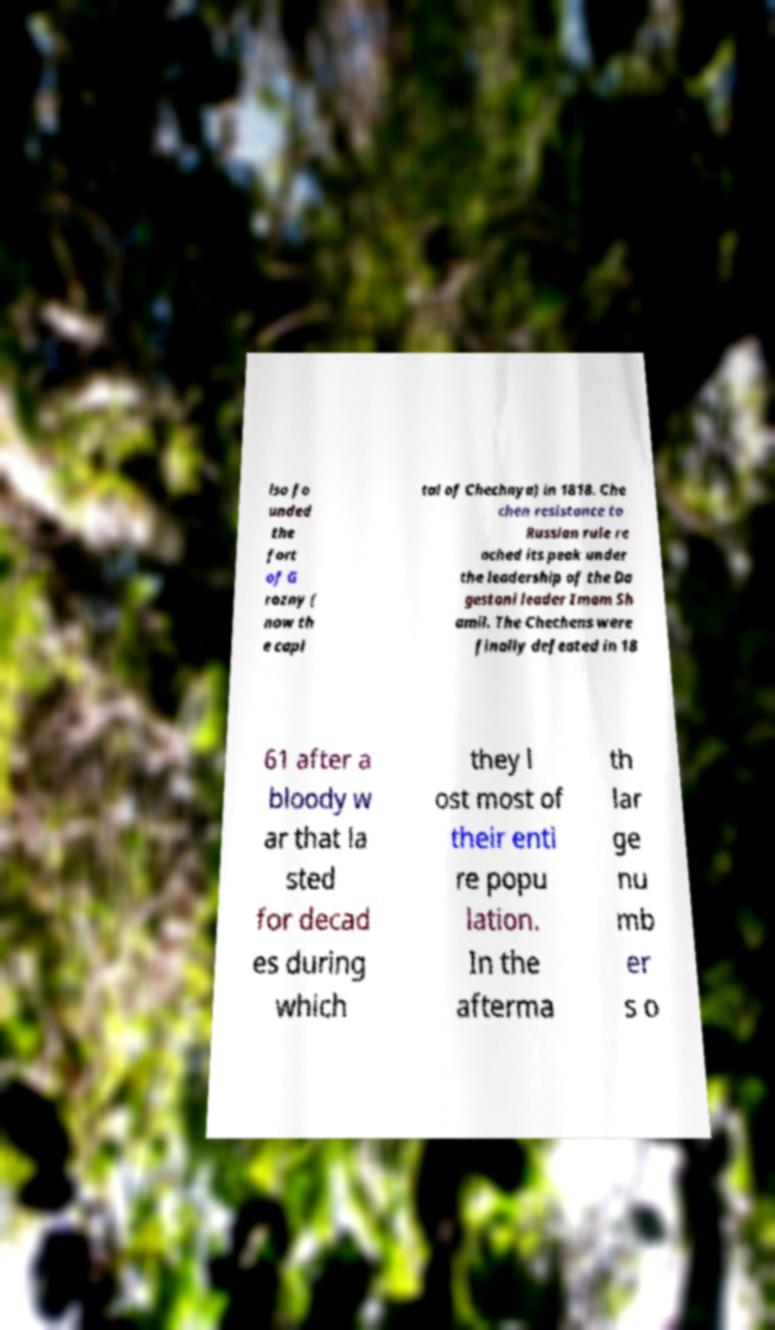Please identify and transcribe the text found in this image. lso fo unded the fort of G rozny ( now th e capi tal of Chechnya) in 1818. Che chen resistance to Russian rule re ached its peak under the leadership of the Da gestani leader Imam Sh amil. The Chechens were finally defeated in 18 61 after a bloody w ar that la sted for decad es during which they l ost most of their enti re popu lation. In the afterma th lar ge nu mb er s o 